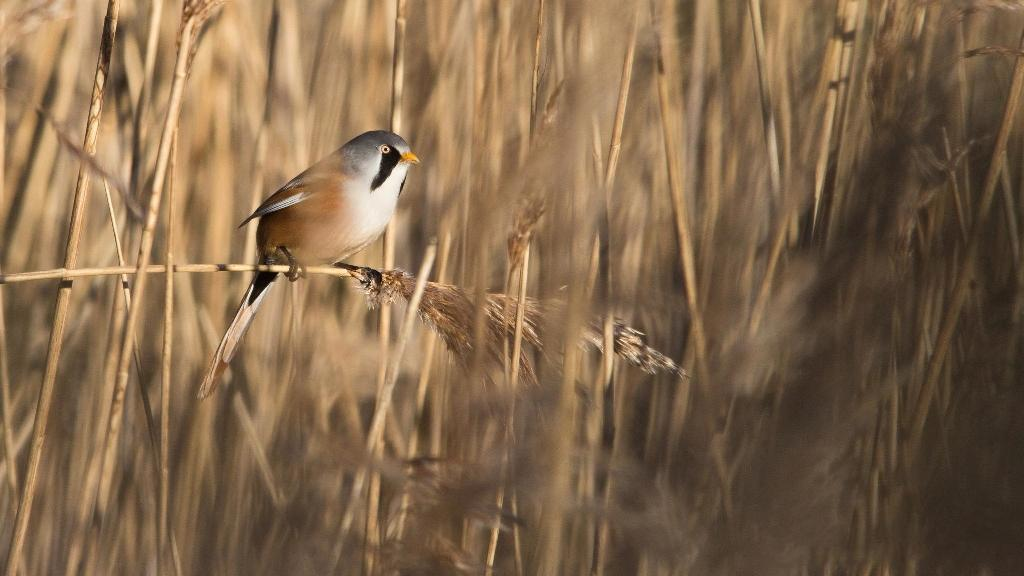What type of animal can be seen in the image? There is a bird in the image. What can be seen in the background of the image? There are plants in the background of the image. What type of string is the bird using to hold its degree in the image? There is no string or degree present in the image; it features a bird and plants in the background. 